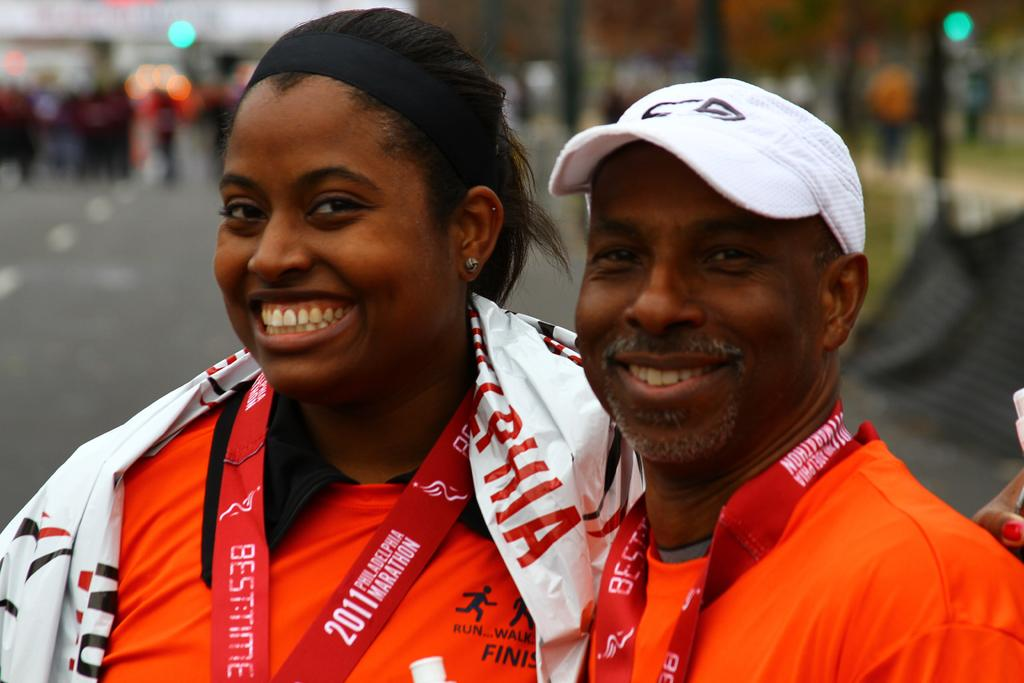How many people are in the image? There are two persons in the image. Can you describe any distinguishing features of the persons? One of the persons has text on a tag associated with them. What can be observed about the background of the image? The background of the image is blurred. What type of cat can be seen walking in the background of the image? There is no cat present in the image, and the background is blurred, so it is not possible to see any walking animals. 